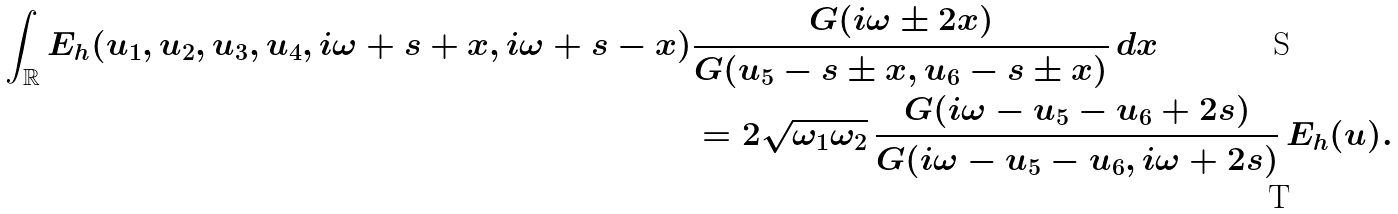Convert formula to latex. <formula><loc_0><loc_0><loc_500><loc_500>\int _ { \mathbb { R } } E _ { h } ( u _ { 1 } , u _ { 2 } , u _ { 3 } , u _ { 4 } , i \omega + s + x , i \omega + s - x ) & \frac { G ( i \omega \pm 2 x ) } { G ( u _ { 5 } - s \pm x , u _ { 6 } - s \pm x ) } \, d x \\ & = 2 \sqrt { \omega _ { 1 } \omega _ { 2 } } \, \frac { G ( i \omega - u _ { 5 } - u _ { 6 } + 2 s ) } { G ( i \omega - u _ { 5 } - u _ { 6 } , i \omega + 2 s ) } \, E _ { h } ( u ) .</formula> 